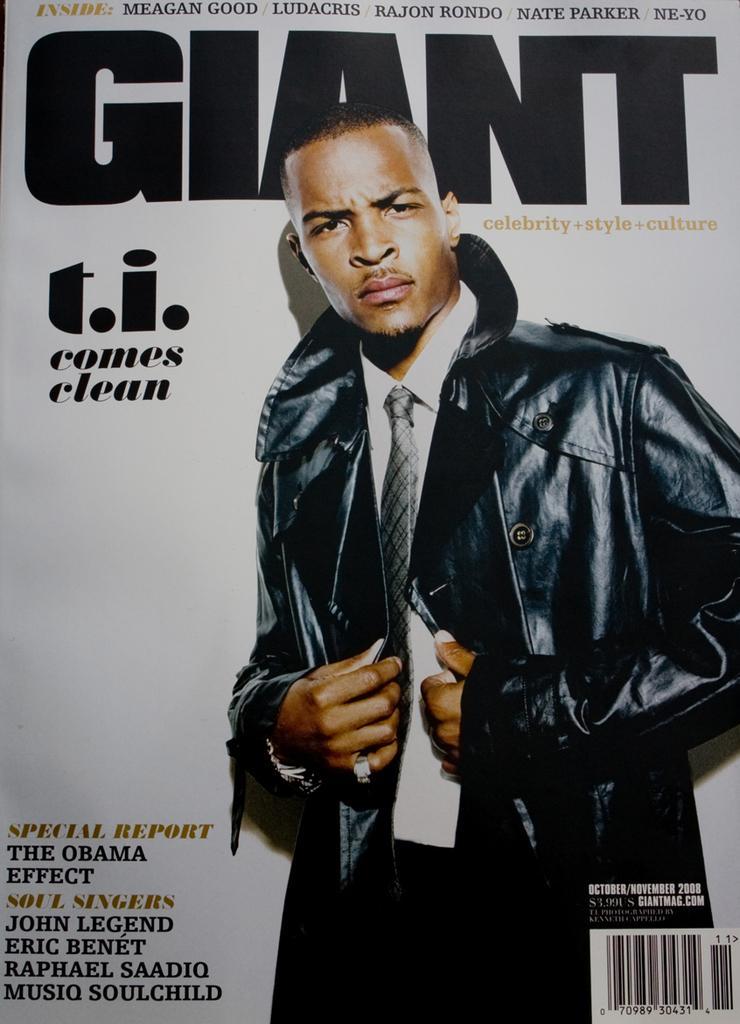Please provide a concise description of this image. In this image there is a picture of a person with some text on a magazine cover. 